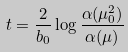<formula> <loc_0><loc_0><loc_500><loc_500>t = \frac { 2 } { b _ { 0 } } \log \frac { \alpha ( \mu _ { 0 } ^ { 2 } ) } { \alpha ( \mu ) }</formula> 